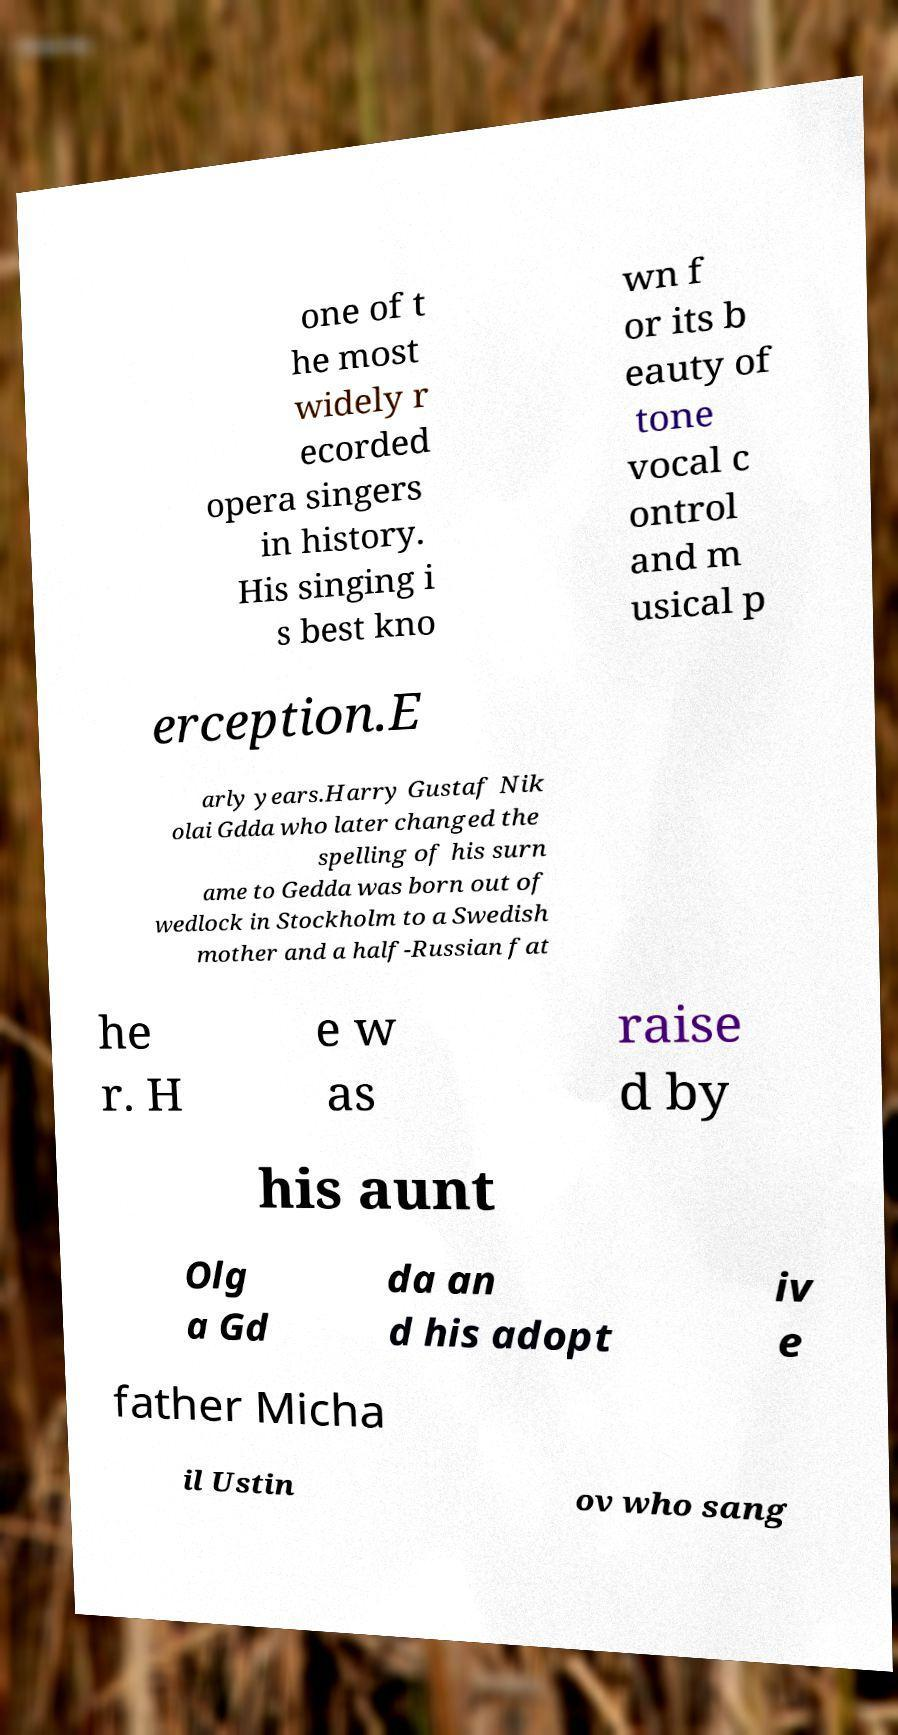What messages or text are displayed in this image? I need them in a readable, typed format. one of t he most widely r ecorded opera singers in history. His singing i s best kno wn f or its b eauty of tone vocal c ontrol and m usical p erception.E arly years.Harry Gustaf Nik olai Gdda who later changed the spelling of his surn ame to Gedda was born out of wedlock in Stockholm to a Swedish mother and a half-Russian fat he r. H e w as raise d by his aunt Olg a Gd da an d his adopt iv e father Micha il Ustin ov who sang 